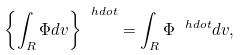Convert formula to latex. <formula><loc_0><loc_0><loc_500><loc_500>\left \{ \int _ { R } \Phi d v \right \} ^ { \ h d o t } = \int _ { R } \Phi ^ { \ h d o t } d v ,</formula> 